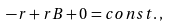<formula> <loc_0><loc_0><loc_500><loc_500>- r + r B + 0 = c o n s t . \, ,</formula> 